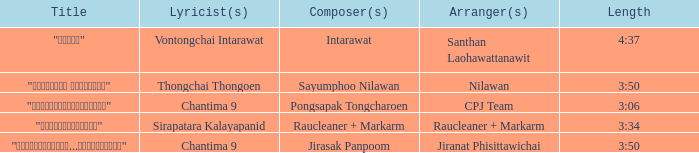Who was the composer of "ขอโทษ"? Intarawat. 